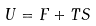<formula> <loc_0><loc_0><loc_500><loc_500>U = F + T S</formula> 